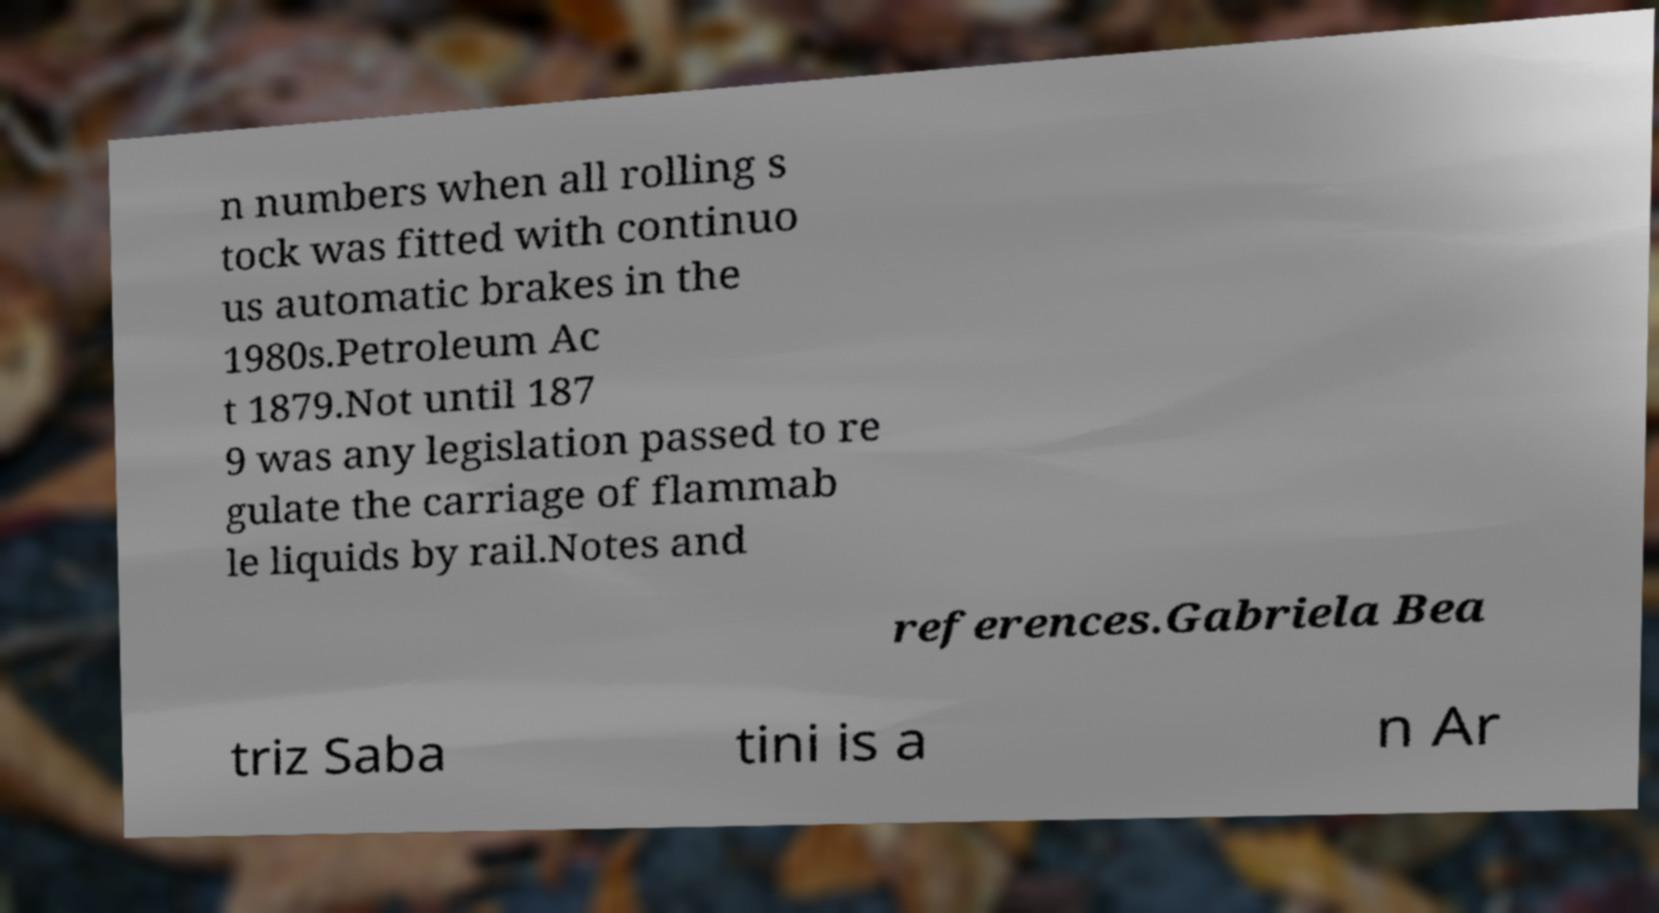Could you extract and type out the text from this image? n numbers when all rolling s tock was fitted with continuo us automatic brakes in the 1980s.Petroleum Ac t 1879.Not until 187 9 was any legislation passed to re gulate the carriage of flammab le liquids by rail.Notes and references.Gabriela Bea triz Saba tini is a n Ar 